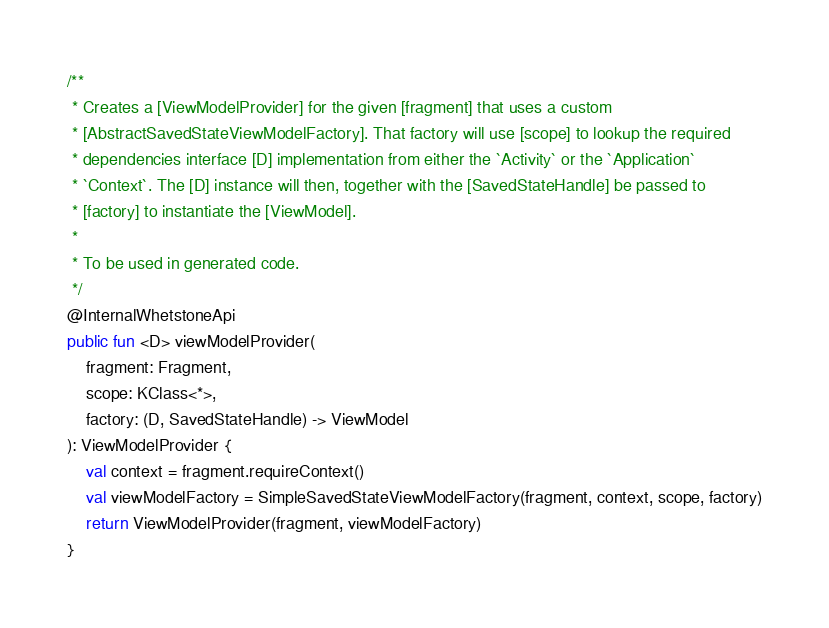Convert code to text. <code><loc_0><loc_0><loc_500><loc_500><_Kotlin_>/**
 * Creates a [ViewModelProvider] for the given [fragment] that uses a custom
 * [AbstractSavedStateViewModelFactory]. That factory will use [scope] to lookup the required
 * dependencies interface [D] implementation from either the `Activity` or the `Application`
 * `Context`. The [D] instance will then, together with the [SavedStateHandle] be passed to
 * [factory] to instantiate the [ViewModel].
 *
 * To be used in generated code.
 */
@InternalWhetstoneApi
public fun <D> viewModelProvider(
    fragment: Fragment,
    scope: KClass<*>,
    factory: (D, SavedStateHandle) -> ViewModel
): ViewModelProvider {
    val context = fragment.requireContext()
    val viewModelFactory = SimpleSavedStateViewModelFactory(fragment, context, scope, factory)
    return ViewModelProvider(fragment, viewModelFactory)
}
</code> 